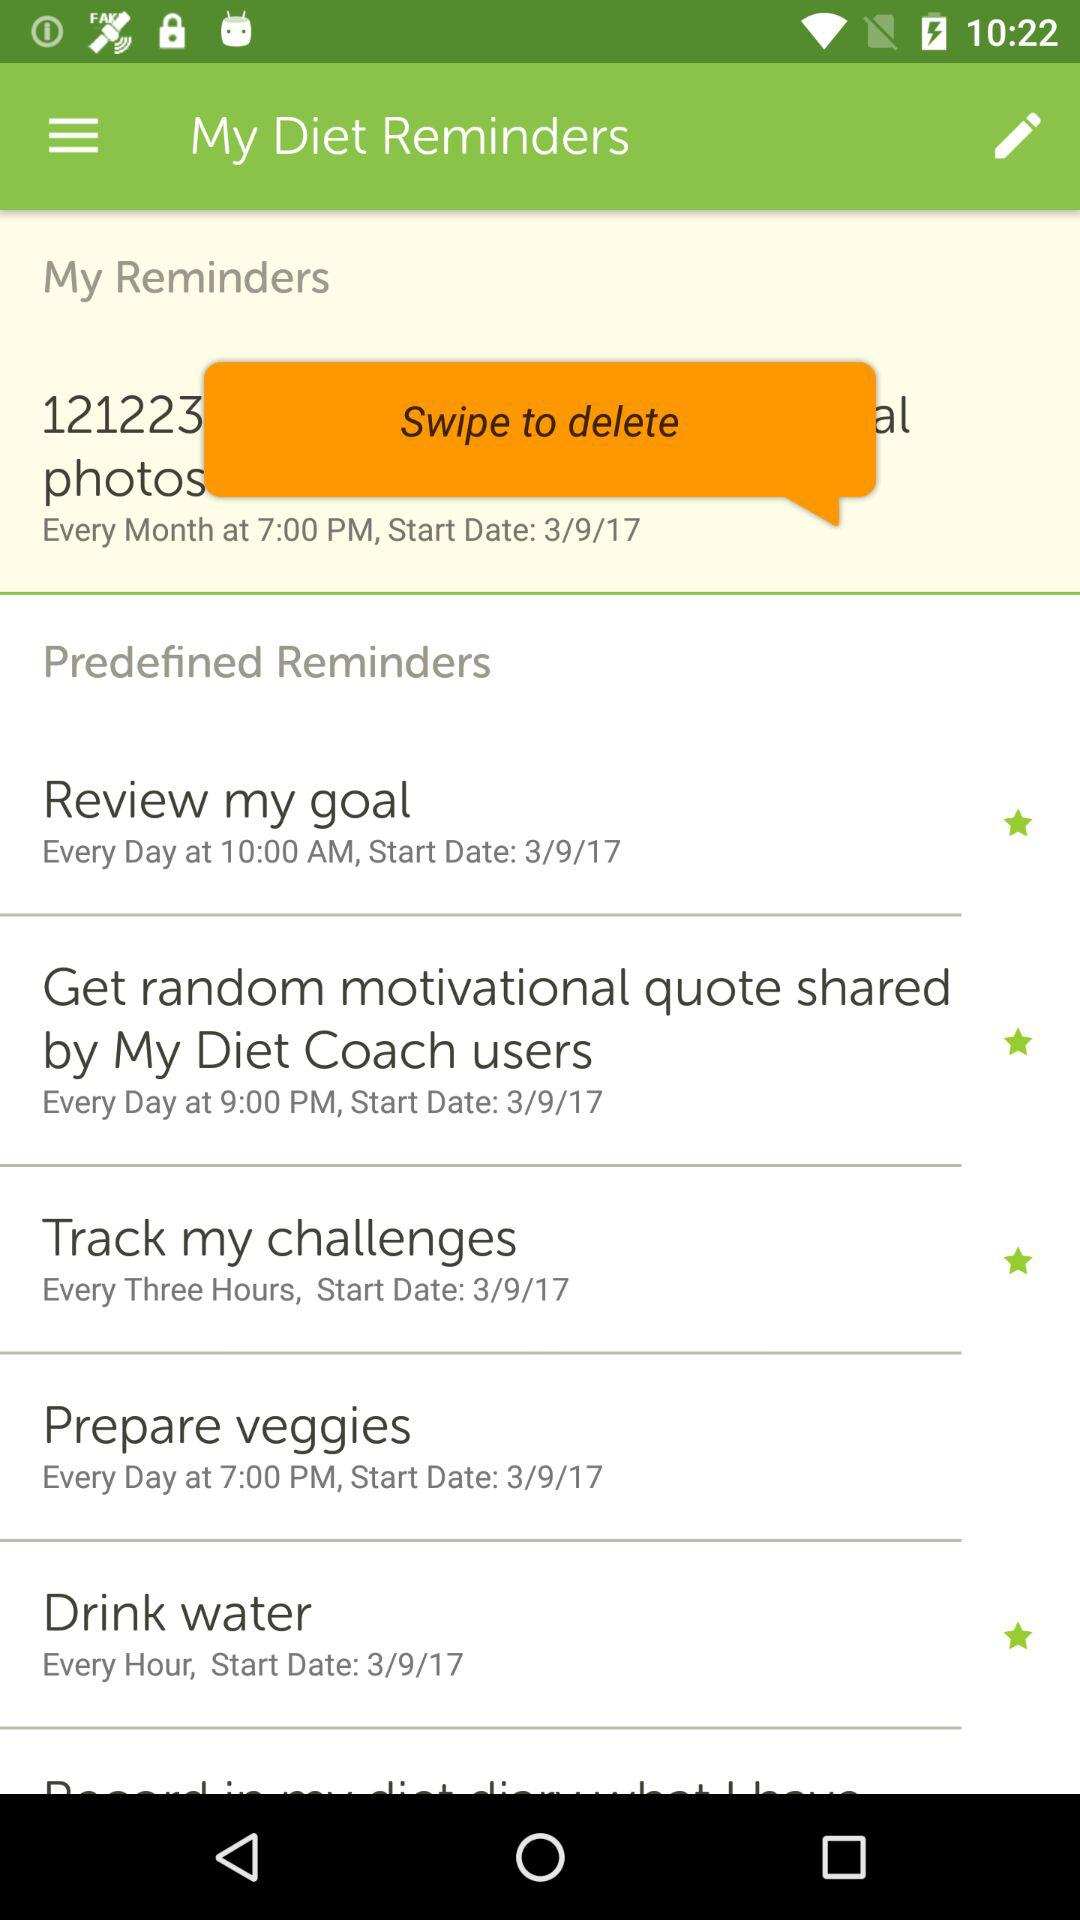What is the start date for "Review my goal"? The start date is March 9, 2017. 